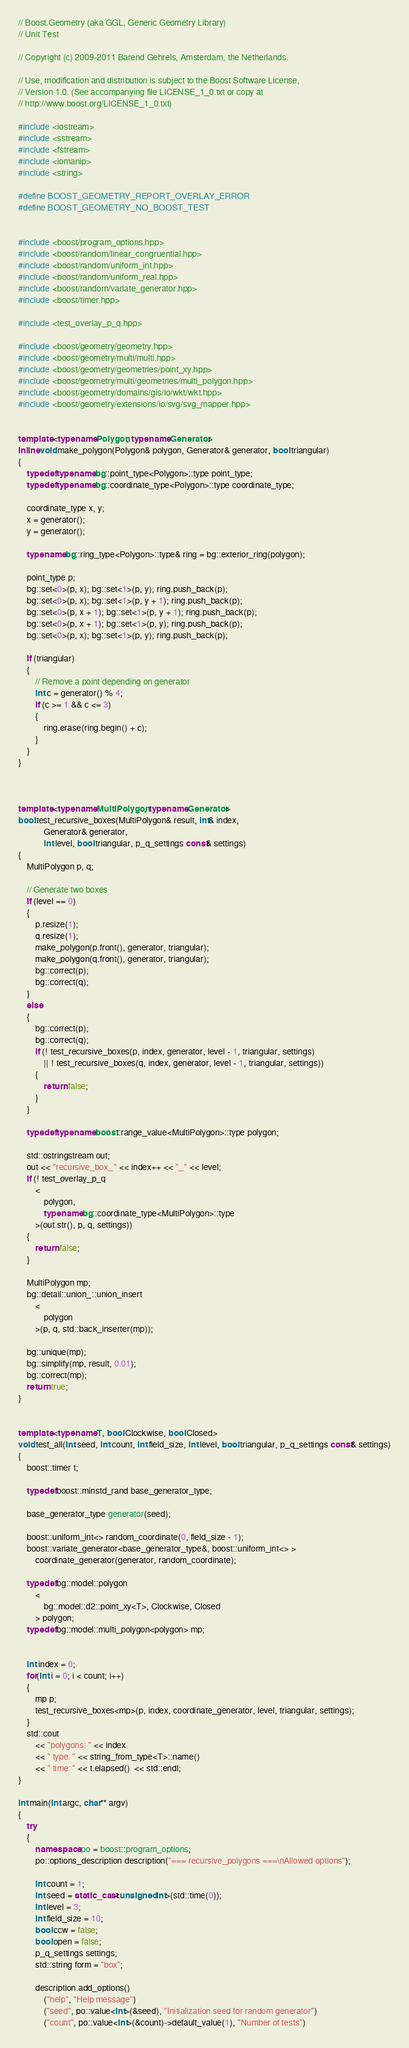Convert code to text. <code><loc_0><loc_0><loc_500><loc_500><_C++_>// Boost.Geometry (aka GGL, Generic Geometry Library)
// Unit Test

// Copyright (c) 2009-2011 Barend Gehrels, Amsterdam, the Netherlands.

// Use, modification and distribution is subject to the Boost Software License,
// Version 1.0. (See accompanying file LICENSE_1_0.txt or copy at
// http://www.boost.org/LICENSE_1_0.txt)

#include <iostream>
#include <sstream>
#include <fstream>
#include <iomanip>
#include <string>

#define BOOST_GEOMETRY_REPORT_OVERLAY_ERROR
#define BOOST_GEOMETRY_NO_BOOST_TEST


#include <boost/program_options.hpp>
#include <boost/random/linear_congruential.hpp>
#include <boost/random/uniform_int.hpp>
#include <boost/random/uniform_real.hpp>
#include <boost/random/variate_generator.hpp>
#include <boost/timer.hpp>

#include <test_overlay_p_q.hpp>

#include <boost/geometry/geometry.hpp>
#include <boost/geometry/multi/multi.hpp>
#include <boost/geometry/geometries/point_xy.hpp>
#include <boost/geometry/multi/geometries/multi_polygon.hpp>
#include <boost/geometry/domains/gis/io/wkt/wkt.hpp>
#include <boost/geometry/extensions/io/svg/svg_mapper.hpp>


template <typename Polygon, typename Generator>
inline void make_polygon(Polygon& polygon, Generator& generator, bool triangular)
{
    typedef typename bg::point_type<Polygon>::type point_type;
    typedef typename bg::coordinate_type<Polygon>::type coordinate_type;

    coordinate_type x, y;
    x = generator();
    y = generator();

    typename bg::ring_type<Polygon>::type& ring = bg::exterior_ring(polygon);

    point_type p;
    bg::set<0>(p, x); bg::set<1>(p, y); ring.push_back(p);
    bg::set<0>(p, x); bg::set<1>(p, y + 1); ring.push_back(p);
    bg::set<0>(p, x + 1); bg::set<1>(p, y + 1); ring.push_back(p);
    bg::set<0>(p, x + 1); bg::set<1>(p, y); ring.push_back(p);
    bg::set<0>(p, x); bg::set<1>(p, y); ring.push_back(p);

    if (triangular)
    {
        // Remove a point depending on generator
        int c = generator() % 4;
        if (c >= 1 && c <= 3)
        {
            ring.erase(ring.begin() + c);
        }
    }
}



template <typename MultiPolygon, typename Generator>
bool test_recursive_boxes(MultiPolygon& result, int& index,
            Generator& generator,
            int level, bool triangular, p_q_settings const& settings)
{
    MultiPolygon p, q;

    // Generate two boxes
    if (level == 0)
    {
        p.resize(1);
        q.resize(1);
        make_polygon(p.front(), generator, triangular);
        make_polygon(q.front(), generator, triangular);
        bg::correct(p);
        bg::correct(q);
    }
    else
    {
        bg::correct(p);
        bg::correct(q);
        if (! test_recursive_boxes(p, index, generator, level - 1, triangular, settings)
            || ! test_recursive_boxes(q, index, generator, level - 1, triangular, settings))
        {
            return false;
        }
    }

    typedef typename boost::range_value<MultiPolygon>::type polygon;

    std::ostringstream out;
    out << "recursive_box_" << index++ << "_" << level;
    if (! test_overlay_p_q
        <
            polygon,
            typename bg::coordinate_type<MultiPolygon>::type
        >(out.str(), p, q, settings))
    {
        return false;
    }

    MultiPolygon mp;
    bg::detail::union_::union_insert
        <
            polygon
        >(p, q, std::back_inserter(mp));

    bg::unique(mp);
    bg::simplify(mp, result, 0.01);
    bg::correct(mp);
    return true;
}


template <typename T, bool Clockwise, bool Closed>
void test_all(int seed, int count, int field_size, int level, bool triangular, p_q_settings const& settings)
{
    boost::timer t;

    typedef boost::minstd_rand base_generator_type;

    base_generator_type generator(seed);

    boost::uniform_int<> random_coordinate(0, field_size - 1);
    boost::variate_generator<base_generator_type&, boost::uniform_int<> >
        coordinate_generator(generator, random_coordinate);

    typedef bg::model::polygon
        <
            bg::model::d2::point_xy<T>, Clockwise, Closed
        > polygon;
    typedef bg::model::multi_polygon<polygon> mp;


    int index = 0;
    for(int i = 0; i < count; i++)
    {
        mp p;
        test_recursive_boxes<mp>(p, index, coordinate_generator, level, triangular, settings);
    }
    std::cout
        << "polygons: " << index
        << " type: " << string_from_type<T>::name()
        << " time: " << t.elapsed()  << std::endl;
}

int main(int argc, char** argv)
{
    try
    {
        namespace po = boost::program_options;
        po::options_description description("=== recursive_polygons ===\nAllowed options");

        int count = 1;
        int seed = static_cast<unsigned int>(std::time(0));
        int level = 3;
        int field_size = 10;
        bool ccw = false;
        bool open = false;
        p_q_settings settings;
        std::string form = "box";

        description.add_options()
            ("help", "Help message")
            ("seed", po::value<int>(&seed), "Initialization seed for random generator")
            ("count", po::value<int>(&count)->default_value(1), "Number of tests")</code> 